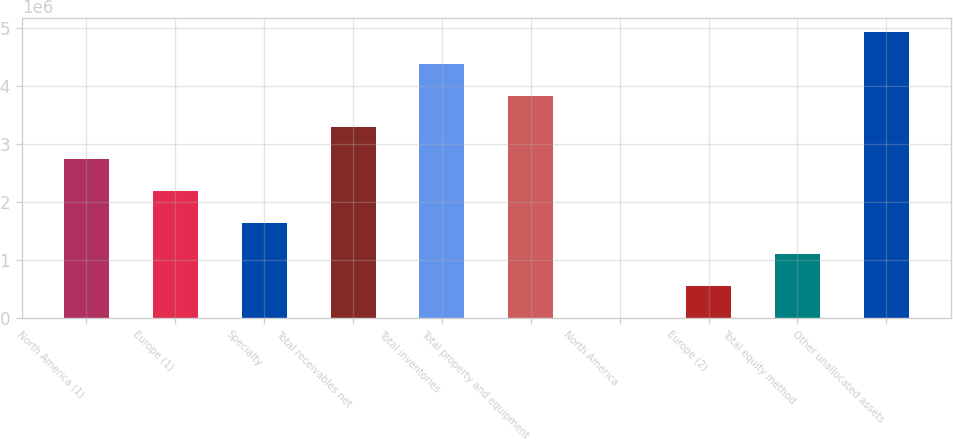<chart> <loc_0><loc_0><loc_500><loc_500><bar_chart><fcel>North America (1)<fcel>Europe (1)<fcel>Specialty<fcel>Total receivables net<fcel>Total inventories<fcel>Total property and equipment<fcel>North America<fcel>Europe (2)<fcel>Total equity method<fcel>Other unallocated assets<nl><fcel>2.73814e+06<fcel>2.19062e+06<fcel>1.6431e+06<fcel>3.28566e+06<fcel>4.3807e+06<fcel>3.83318e+06<fcel>536<fcel>548056<fcel>1.09558e+06<fcel>4.92822e+06<nl></chart> 